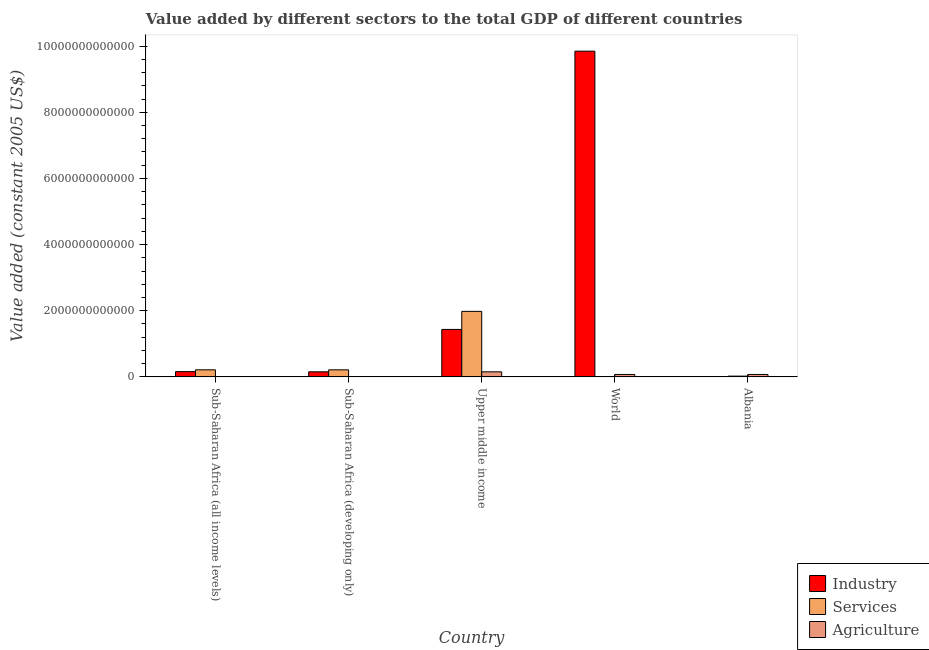How many different coloured bars are there?
Offer a very short reply. 3. How many groups of bars are there?
Ensure brevity in your answer.  5. Are the number of bars per tick equal to the number of legend labels?
Your response must be concise. Yes. How many bars are there on the 1st tick from the left?
Ensure brevity in your answer.  3. How many bars are there on the 1st tick from the right?
Ensure brevity in your answer.  3. What is the label of the 3rd group of bars from the left?
Your response must be concise. Upper middle income. In how many cases, is the number of bars for a given country not equal to the number of legend labels?
Your answer should be very brief. 0. What is the value added by industrial sector in Albania?
Provide a short and direct response. 7.94e+08. Across all countries, what is the maximum value added by industrial sector?
Ensure brevity in your answer.  9.85e+12. Across all countries, what is the minimum value added by industrial sector?
Offer a terse response. 7.94e+08. In which country was the value added by industrial sector maximum?
Make the answer very short. World. In which country was the value added by agricultural sector minimum?
Make the answer very short. Sub-Saharan Africa (all income levels). What is the total value added by agricultural sector in the graph?
Your answer should be very brief. 3.05e+11. What is the difference between the value added by services in Albania and that in Sub-Saharan Africa (all income levels)?
Keep it short and to the point. -1.90e+11. What is the difference between the value added by services in Sub-Saharan Africa (developing only) and the value added by agricultural sector in Albania?
Give a very brief answer. 1.40e+11. What is the average value added by industrial sector per country?
Ensure brevity in your answer.  2.32e+12. What is the difference between the value added by industrial sector and value added by services in World?
Your answer should be very brief. 9.84e+12. What is the ratio of the value added by agricultural sector in Sub-Saharan Africa (all income levels) to that in Sub-Saharan Africa (developing only)?
Ensure brevity in your answer.  0.14. Is the value added by agricultural sector in Sub-Saharan Africa (all income levels) less than that in World?
Offer a very short reply. Yes. What is the difference between the highest and the second highest value added by industrial sector?
Ensure brevity in your answer.  8.41e+12. What is the difference between the highest and the lowest value added by industrial sector?
Make the answer very short. 9.85e+12. In how many countries, is the value added by agricultural sector greater than the average value added by agricultural sector taken over all countries?
Your answer should be very brief. 3. Is the sum of the value added by services in Sub-Saharan Africa (all income levels) and Upper middle income greater than the maximum value added by industrial sector across all countries?
Provide a succinct answer. No. What does the 3rd bar from the left in Sub-Saharan Africa (developing only) represents?
Provide a succinct answer. Agriculture. What does the 3rd bar from the right in Sub-Saharan Africa (developing only) represents?
Ensure brevity in your answer.  Industry. What is the difference between two consecutive major ticks on the Y-axis?
Provide a succinct answer. 2.00e+12. Are the values on the major ticks of Y-axis written in scientific E-notation?
Your answer should be compact. No. Does the graph contain grids?
Offer a very short reply. No. Where does the legend appear in the graph?
Make the answer very short. Bottom right. How many legend labels are there?
Offer a very short reply. 3. How are the legend labels stacked?
Provide a succinct answer. Vertical. What is the title of the graph?
Provide a succinct answer. Value added by different sectors to the total GDP of different countries. What is the label or title of the Y-axis?
Provide a succinct answer. Value added (constant 2005 US$). What is the Value added (constant 2005 US$) in Industry in Sub-Saharan Africa (all income levels)?
Provide a succinct answer. 1.59e+11. What is the Value added (constant 2005 US$) in Services in Sub-Saharan Africa (all income levels)?
Offer a terse response. 2.13e+11. What is the Value added (constant 2005 US$) of Agriculture in Sub-Saharan Africa (all income levels)?
Keep it short and to the point. 7.92e+08. What is the Value added (constant 2005 US$) of Industry in Sub-Saharan Africa (developing only)?
Provide a short and direct response. 1.53e+11. What is the Value added (constant 2005 US$) in Services in Sub-Saharan Africa (developing only)?
Ensure brevity in your answer.  2.13e+11. What is the Value added (constant 2005 US$) in Agriculture in Sub-Saharan Africa (developing only)?
Your response must be concise. 5.75e+09. What is the Value added (constant 2005 US$) of Industry in Upper middle income?
Offer a very short reply. 1.43e+12. What is the Value added (constant 2005 US$) in Services in Upper middle income?
Your answer should be very brief. 1.98e+12. What is the Value added (constant 2005 US$) in Agriculture in Upper middle income?
Provide a short and direct response. 1.52e+11. What is the Value added (constant 2005 US$) of Industry in World?
Your answer should be very brief. 9.85e+12. What is the Value added (constant 2005 US$) of Services in World?
Give a very brief answer. 3.16e+09. What is the Value added (constant 2005 US$) in Agriculture in World?
Ensure brevity in your answer.  7.29e+1. What is the Value added (constant 2005 US$) in Industry in Albania?
Provide a succinct answer. 7.94e+08. What is the Value added (constant 2005 US$) of Services in Albania?
Your answer should be compact. 2.30e+1. What is the Value added (constant 2005 US$) in Agriculture in Albania?
Your response must be concise. 7.28e+1. Across all countries, what is the maximum Value added (constant 2005 US$) in Industry?
Provide a short and direct response. 9.85e+12. Across all countries, what is the maximum Value added (constant 2005 US$) of Services?
Your answer should be very brief. 1.98e+12. Across all countries, what is the maximum Value added (constant 2005 US$) in Agriculture?
Offer a terse response. 1.52e+11. Across all countries, what is the minimum Value added (constant 2005 US$) in Industry?
Give a very brief answer. 7.94e+08. Across all countries, what is the minimum Value added (constant 2005 US$) in Services?
Provide a succinct answer. 3.16e+09. Across all countries, what is the minimum Value added (constant 2005 US$) in Agriculture?
Offer a terse response. 7.92e+08. What is the total Value added (constant 2005 US$) of Industry in the graph?
Offer a very short reply. 1.16e+13. What is the total Value added (constant 2005 US$) of Services in the graph?
Offer a very short reply. 2.43e+12. What is the total Value added (constant 2005 US$) in Agriculture in the graph?
Ensure brevity in your answer.  3.05e+11. What is the difference between the Value added (constant 2005 US$) in Industry in Sub-Saharan Africa (all income levels) and that in Sub-Saharan Africa (developing only)?
Provide a short and direct response. 5.85e+09. What is the difference between the Value added (constant 2005 US$) in Services in Sub-Saharan Africa (all income levels) and that in Sub-Saharan Africa (developing only)?
Make the answer very short. 6.67e+08. What is the difference between the Value added (constant 2005 US$) of Agriculture in Sub-Saharan Africa (all income levels) and that in Sub-Saharan Africa (developing only)?
Give a very brief answer. -4.96e+09. What is the difference between the Value added (constant 2005 US$) of Industry in Sub-Saharan Africa (all income levels) and that in Upper middle income?
Your response must be concise. -1.28e+12. What is the difference between the Value added (constant 2005 US$) in Services in Sub-Saharan Africa (all income levels) and that in Upper middle income?
Offer a very short reply. -1.77e+12. What is the difference between the Value added (constant 2005 US$) of Agriculture in Sub-Saharan Africa (all income levels) and that in Upper middle income?
Offer a terse response. -1.52e+11. What is the difference between the Value added (constant 2005 US$) in Industry in Sub-Saharan Africa (all income levels) and that in World?
Offer a very short reply. -9.69e+12. What is the difference between the Value added (constant 2005 US$) in Services in Sub-Saharan Africa (all income levels) and that in World?
Give a very brief answer. 2.10e+11. What is the difference between the Value added (constant 2005 US$) of Agriculture in Sub-Saharan Africa (all income levels) and that in World?
Your answer should be very brief. -7.21e+1. What is the difference between the Value added (constant 2005 US$) in Industry in Sub-Saharan Africa (all income levels) and that in Albania?
Your answer should be very brief. 1.58e+11. What is the difference between the Value added (constant 2005 US$) in Services in Sub-Saharan Africa (all income levels) and that in Albania?
Make the answer very short. 1.90e+11. What is the difference between the Value added (constant 2005 US$) in Agriculture in Sub-Saharan Africa (all income levels) and that in Albania?
Your response must be concise. -7.20e+1. What is the difference between the Value added (constant 2005 US$) in Industry in Sub-Saharan Africa (developing only) and that in Upper middle income?
Offer a very short reply. -1.28e+12. What is the difference between the Value added (constant 2005 US$) in Services in Sub-Saharan Africa (developing only) and that in Upper middle income?
Keep it short and to the point. -1.77e+12. What is the difference between the Value added (constant 2005 US$) in Agriculture in Sub-Saharan Africa (developing only) and that in Upper middle income?
Offer a terse response. -1.47e+11. What is the difference between the Value added (constant 2005 US$) in Industry in Sub-Saharan Africa (developing only) and that in World?
Your response must be concise. -9.69e+12. What is the difference between the Value added (constant 2005 US$) in Services in Sub-Saharan Africa (developing only) and that in World?
Your answer should be very brief. 2.10e+11. What is the difference between the Value added (constant 2005 US$) of Agriculture in Sub-Saharan Africa (developing only) and that in World?
Keep it short and to the point. -6.72e+1. What is the difference between the Value added (constant 2005 US$) in Industry in Sub-Saharan Africa (developing only) and that in Albania?
Ensure brevity in your answer.  1.52e+11. What is the difference between the Value added (constant 2005 US$) of Services in Sub-Saharan Africa (developing only) and that in Albania?
Make the answer very short. 1.90e+11. What is the difference between the Value added (constant 2005 US$) in Agriculture in Sub-Saharan Africa (developing only) and that in Albania?
Your answer should be compact. -6.70e+1. What is the difference between the Value added (constant 2005 US$) of Industry in Upper middle income and that in World?
Ensure brevity in your answer.  -8.41e+12. What is the difference between the Value added (constant 2005 US$) of Services in Upper middle income and that in World?
Your response must be concise. 1.98e+12. What is the difference between the Value added (constant 2005 US$) of Agriculture in Upper middle income and that in World?
Ensure brevity in your answer.  7.95e+1. What is the difference between the Value added (constant 2005 US$) of Industry in Upper middle income and that in Albania?
Give a very brief answer. 1.43e+12. What is the difference between the Value added (constant 2005 US$) in Services in Upper middle income and that in Albania?
Offer a very short reply. 1.96e+12. What is the difference between the Value added (constant 2005 US$) in Agriculture in Upper middle income and that in Albania?
Ensure brevity in your answer.  7.96e+1. What is the difference between the Value added (constant 2005 US$) in Industry in World and that in Albania?
Offer a terse response. 9.85e+12. What is the difference between the Value added (constant 2005 US$) of Services in World and that in Albania?
Offer a terse response. -1.98e+1. What is the difference between the Value added (constant 2005 US$) in Agriculture in World and that in Albania?
Offer a terse response. 1.69e+08. What is the difference between the Value added (constant 2005 US$) of Industry in Sub-Saharan Africa (all income levels) and the Value added (constant 2005 US$) of Services in Sub-Saharan Africa (developing only)?
Give a very brief answer. -5.36e+1. What is the difference between the Value added (constant 2005 US$) of Industry in Sub-Saharan Africa (all income levels) and the Value added (constant 2005 US$) of Agriculture in Sub-Saharan Africa (developing only)?
Your response must be concise. 1.53e+11. What is the difference between the Value added (constant 2005 US$) of Services in Sub-Saharan Africa (all income levels) and the Value added (constant 2005 US$) of Agriculture in Sub-Saharan Africa (developing only)?
Provide a short and direct response. 2.08e+11. What is the difference between the Value added (constant 2005 US$) of Industry in Sub-Saharan Africa (all income levels) and the Value added (constant 2005 US$) of Services in Upper middle income?
Your response must be concise. -1.82e+12. What is the difference between the Value added (constant 2005 US$) of Industry in Sub-Saharan Africa (all income levels) and the Value added (constant 2005 US$) of Agriculture in Upper middle income?
Your answer should be very brief. 6.68e+09. What is the difference between the Value added (constant 2005 US$) of Services in Sub-Saharan Africa (all income levels) and the Value added (constant 2005 US$) of Agriculture in Upper middle income?
Keep it short and to the point. 6.10e+1. What is the difference between the Value added (constant 2005 US$) of Industry in Sub-Saharan Africa (all income levels) and the Value added (constant 2005 US$) of Services in World?
Keep it short and to the point. 1.56e+11. What is the difference between the Value added (constant 2005 US$) of Industry in Sub-Saharan Africa (all income levels) and the Value added (constant 2005 US$) of Agriculture in World?
Your answer should be compact. 8.62e+1. What is the difference between the Value added (constant 2005 US$) in Services in Sub-Saharan Africa (all income levels) and the Value added (constant 2005 US$) in Agriculture in World?
Your answer should be very brief. 1.40e+11. What is the difference between the Value added (constant 2005 US$) of Industry in Sub-Saharan Africa (all income levels) and the Value added (constant 2005 US$) of Services in Albania?
Offer a very short reply. 1.36e+11. What is the difference between the Value added (constant 2005 US$) in Industry in Sub-Saharan Africa (all income levels) and the Value added (constant 2005 US$) in Agriculture in Albania?
Provide a succinct answer. 8.63e+1. What is the difference between the Value added (constant 2005 US$) in Services in Sub-Saharan Africa (all income levels) and the Value added (constant 2005 US$) in Agriculture in Albania?
Offer a terse response. 1.41e+11. What is the difference between the Value added (constant 2005 US$) of Industry in Sub-Saharan Africa (developing only) and the Value added (constant 2005 US$) of Services in Upper middle income?
Ensure brevity in your answer.  -1.83e+12. What is the difference between the Value added (constant 2005 US$) of Industry in Sub-Saharan Africa (developing only) and the Value added (constant 2005 US$) of Agriculture in Upper middle income?
Offer a terse response. 8.36e+08. What is the difference between the Value added (constant 2005 US$) of Services in Sub-Saharan Africa (developing only) and the Value added (constant 2005 US$) of Agriculture in Upper middle income?
Ensure brevity in your answer.  6.03e+1. What is the difference between the Value added (constant 2005 US$) in Industry in Sub-Saharan Africa (developing only) and the Value added (constant 2005 US$) in Services in World?
Your answer should be compact. 1.50e+11. What is the difference between the Value added (constant 2005 US$) of Industry in Sub-Saharan Africa (developing only) and the Value added (constant 2005 US$) of Agriculture in World?
Your answer should be very brief. 8.03e+1. What is the difference between the Value added (constant 2005 US$) of Services in Sub-Saharan Africa (developing only) and the Value added (constant 2005 US$) of Agriculture in World?
Give a very brief answer. 1.40e+11. What is the difference between the Value added (constant 2005 US$) of Industry in Sub-Saharan Africa (developing only) and the Value added (constant 2005 US$) of Services in Albania?
Your answer should be very brief. 1.30e+11. What is the difference between the Value added (constant 2005 US$) in Industry in Sub-Saharan Africa (developing only) and the Value added (constant 2005 US$) in Agriculture in Albania?
Your answer should be very brief. 8.05e+1. What is the difference between the Value added (constant 2005 US$) of Services in Sub-Saharan Africa (developing only) and the Value added (constant 2005 US$) of Agriculture in Albania?
Your answer should be compact. 1.40e+11. What is the difference between the Value added (constant 2005 US$) in Industry in Upper middle income and the Value added (constant 2005 US$) in Services in World?
Make the answer very short. 1.43e+12. What is the difference between the Value added (constant 2005 US$) in Industry in Upper middle income and the Value added (constant 2005 US$) in Agriculture in World?
Your answer should be very brief. 1.36e+12. What is the difference between the Value added (constant 2005 US$) in Services in Upper middle income and the Value added (constant 2005 US$) in Agriculture in World?
Give a very brief answer. 1.91e+12. What is the difference between the Value added (constant 2005 US$) of Industry in Upper middle income and the Value added (constant 2005 US$) of Services in Albania?
Keep it short and to the point. 1.41e+12. What is the difference between the Value added (constant 2005 US$) of Industry in Upper middle income and the Value added (constant 2005 US$) of Agriculture in Albania?
Offer a terse response. 1.36e+12. What is the difference between the Value added (constant 2005 US$) in Services in Upper middle income and the Value added (constant 2005 US$) in Agriculture in Albania?
Your answer should be very brief. 1.91e+12. What is the difference between the Value added (constant 2005 US$) in Industry in World and the Value added (constant 2005 US$) in Services in Albania?
Your answer should be very brief. 9.82e+12. What is the difference between the Value added (constant 2005 US$) of Industry in World and the Value added (constant 2005 US$) of Agriculture in Albania?
Ensure brevity in your answer.  9.77e+12. What is the difference between the Value added (constant 2005 US$) of Services in World and the Value added (constant 2005 US$) of Agriculture in Albania?
Your answer should be very brief. -6.96e+1. What is the average Value added (constant 2005 US$) in Industry per country?
Ensure brevity in your answer.  2.32e+12. What is the average Value added (constant 2005 US$) of Services per country?
Ensure brevity in your answer.  4.87e+11. What is the average Value added (constant 2005 US$) of Agriculture per country?
Provide a succinct answer. 6.09e+1. What is the difference between the Value added (constant 2005 US$) in Industry and Value added (constant 2005 US$) in Services in Sub-Saharan Africa (all income levels)?
Provide a short and direct response. -5.43e+1. What is the difference between the Value added (constant 2005 US$) of Industry and Value added (constant 2005 US$) of Agriculture in Sub-Saharan Africa (all income levels)?
Provide a short and direct response. 1.58e+11. What is the difference between the Value added (constant 2005 US$) of Services and Value added (constant 2005 US$) of Agriculture in Sub-Saharan Africa (all income levels)?
Ensure brevity in your answer.  2.13e+11. What is the difference between the Value added (constant 2005 US$) of Industry and Value added (constant 2005 US$) of Services in Sub-Saharan Africa (developing only)?
Your answer should be very brief. -5.95e+1. What is the difference between the Value added (constant 2005 US$) of Industry and Value added (constant 2005 US$) of Agriculture in Sub-Saharan Africa (developing only)?
Your answer should be compact. 1.47e+11. What is the difference between the Value added (constant 2005 US$) of Services and Value added (constant 2005 US$) of Agriculture in Sub-Saharan Africa (developing only)?
Offer a very short reply. 2.07e+11. What is the difference between the Value added (constant 2005 US$) in Industry and Value added (constant 2005 US$) in Services in Upper middle income?
Provide a short and direct response. -5.46e+11. What is the difference between the Value added (constant 2005 US$) of Industry and Value added (constant 2005 US$) of Agriculture in Upper middle income?
Your answer should be compact. 1.28e+12. What is the difference between the Value added (constant 2005 US$) in Services and Value added (constant 2005 US$) in Agriculture in Upper middle income?
Ensure brevity in your answer.  1.83e+12. What is the difference between the Value added (constant 2005 US$) of Industry and Value added (constant 2005 US$) of Services in World?
Offer a terse response. 9.84e+12. What is the difference between the Value added (constant 2005 US$) of Industry and Value added (constant 2005 US$) of Agriculture in World?
Your answer should be compact. 9.77e+12. What is the difference between the Value added (constant 2005 US$) of Services and Value added (constant 2005 US$) of Agriculture in World?
Offer a terse response. -6.98e+1. What is the difference between the Value added (constant 2005 US$) of Industry and Value added (constant 2005 US$) of Services in Albania?
Provide a short and direct response. -2.22e+1. What is the difference between the Value added (constant 2005 US$) in Industry and Value added (constant 2005 US$) in Agriculture in Albania?
Give a very brief answer. -7.20e+1. What is the difference between the Value added (constant 2005 US$) in Services and Value added (constant 2005 US$) in Agriculture in Albania?
Provide a short and direct response. -4.98e+1. What is the ratio of the Value added (constant 2005 US$) of Industry in Sub-Saharan Africa (all income levels) to that in Sub-Saharan Africa (developing only)?
Offer a terse response. 1.04. What is the ratio of the Value added (constant 2005 US$) in Agriculture in Sub-Saharan Africa (all income levels) to that in Sub-Saharan Africa (developing only)?
Your response must be concise. 0.14. What is the ratio of the Value added (constant 2005 US$) in Industry in Sub-Saharan Africa (all income levels) to that in Upper middle income?
Ensure brevity in your answer.  0.11. What is the ratio of the Value added (constant 2005 US$) of Services in Sub-Saharan Africa (all income levels) to that in Upper middle income?
Give a very brief answer. 0.11. What is the ratio of the Value added (constant 2005 US$) of Agriculture in Sub-Saharan Africa (all income levels) to that in Upper middle income?
Keep it short and to the point. 0.01. What is the ratio of the Value added (constant 2005 US$) of Industry in Sub-Saharan Africa (all income levels) to that in World?
Keep it short and to the point. 0.02. What is the ratio of the Value added (constant 2005 US$) in Services in Sub-Saharan Africa (all income levels) to that in World?
Provide a short and direct response. 67.51. What is the ratio of the Value added (constant 2005 US$) of Agriculture in Sub-Saharan Africa (all income levels) to that in World?
Provide a short and direct response. 0.01. What is the ratio of the Value added (constant 2005 US$) of Industry in Sub-Saharan Africa (all income levels) to that in Albania?
Your answer should be compact. 200.4. What is the ratio of the Value added (constant 2005 US$) of Services in Sub-Saharan Africa (all income levels) to that in Albania?
Provide a short and direct response. 9.29. What is the ratio of the Value added (constant 2005 US$) of Agriculture in Sub-Saharan Africa (all income levels) to that in Albania?
Provide a succinct answer. 0.01. What is the ratio of the Value added (constant 2005 US$) of Industry in Sub-Saharan Africa (developing only) to that in Upper middle income?
Give a very brief answer. 0.11. What is the ratio of the Value added (constant 2005 US$) in Services in Sub-Saharan Africa (developing only) to that in Upper middle income?
Your answer should be compact. 0.11. What is the ratio of the Value added (constant 2005 US$) in Agriculture in Sub-Saharan Africa (developing only) to that in Upper middle income?
Offer a very short reply. 0.04. What is the ratio of the Value added (constant 2005 US$) of Industry in Sub-Saharan Africa (developing only) to that in World?
Your response must be concise. 0.02. What is the ratio of the Value added (constant 2005 US$) in Services in Sub-Saharan Africa (developing only) to that in World?
Make the answer very short. 67.3. What is the ratio of the Value added (constant 2005 US$) in Agriculture in Sub-Saharan Africa (developing only) to that in World?
Provide a short and direct response. 0.08. What is the ratio of the Value added (constant 2005 US$) in Industry in Sub-Saharan Africa (developing only) to that in Albania?
Provide a short and direct response. 193.03. What is the ratio of the Value added (constant 2005 US$) in Services in Sub-Saharan Africa (developing only) to that in Albania?
Your answer should be compact. 9.26. What is the ratio of the Value added (constant 2005 US$) of Agriculture in Sub-Saharan Africa (developing only) to that in Albania?
Offer a terse response. 0.08. What is the ratio of the Value added (constant 2005 US$) in Industry in Upper middle income to that in World?
Give a very brief answer. 0.15. What is the ratio of the Value added (constant 2005 US$) in Services in Upper middle income to that in World?
Provide a short and direct response. 626.57. What is the ratio of the Value added (constant 2005 US$) of Agriculture in Upper middle income to that in World?
Provide a succinct answer. 2.09. What is the ratio of the Value added (constant 2005 US$) of Industry in Upper middle income to that in Albania?
Your answer should be compact. 1806.87. What is the ratio of the Value added (constant 2005 US$) of Services in Upper middle income to that in Albania?
Ensure brevity in your answer.  86.23. What is the ratio of the Value added (constant 2005 US$) in Agriculture in Upper middle income to that in Albania?
Provide a succinct answer. 2.09. What is the ratio of the Value added (constant 2005 US$) of Industry in World to that in Albania?
Keep it short and to the point. 1.24e+04. What is the ratio of the Value added (constant 2005 US$) in Services in World to that in Albania?
Your response must be concise. 0.14. What is the difference between the highest and the second highest Value added (constant 2005 US$) in Industry?
Ensure brevity in your answer.  8.41e+12. What is the difference between the highest and the second highest Value added (constant 2005 US$) in Services?
Ensure brevity in your answer.  1.77e+12. What is the difference between the highest and the second highest Value added (constant 2005 US$) of Agriculture?
Your response must be concise. 7.95e+1. What is the difference between the highest and the lowest Value added (constant 2005 US$) of Industry?
Offer a very short reply. 9.85e+12. What is the difference between the highest and the lowest Value added (constant 2005 US$) of Services?
Offer a very short reply. 1.98e+12. What is the difference between the highest and the lowest Value added (constant 2005 US$) of Agriculture?
Give a very brief answer. 1.52e+11. 